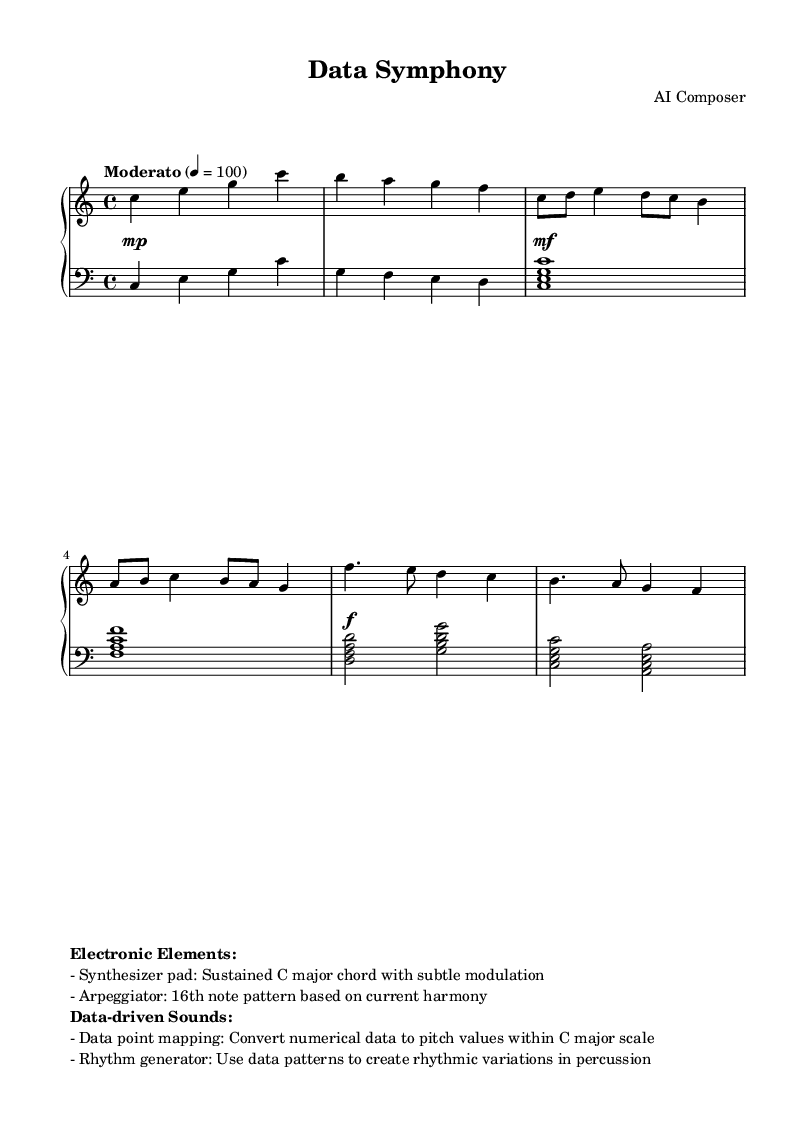What is the key signature of this music? The key signature is C major, which has no sharps or flats indicated on the staff.
Answer: C major What is the time signature of this music? The time signature is indicated as 4/4, which means there are four beats in each measure and the quarter note gets one beat.
Answer: 4/4 What is the tempo marking of this piece? The tempo marking is "Moderato", which suggests a moderate speed, specifically notated as quarter note equals 100 beats per minute.
Answer: Moderato How many measures are in the introduction section? The introduction consists of 2 measures, clearly marked before the thematic sections begin.
Answer: 2 What type of electronic element is suggested in the sheet music? The sheet music mentions a synthesizer pad, which is a specific electronic sound characteristic of contemporary works that incorporate technology.
Answer: Synthesizer pad How is rhythm generated in this piece? The rhythm generator mentioned in the markup indicates that rhythmic variations in percussion are created based on data patterns from the music. This suggests a relationship between data and rhythm.
Answer: Data patterns What are the dynamics indicated for the piece? The dynamics indicated are "piano," "mezzo-forte," and "forte," which suggest varying levels of volume throughout the piece. This is reflected in the dynamics notation present above the staff.
Answer: Piano, mezzo-forte, forte 